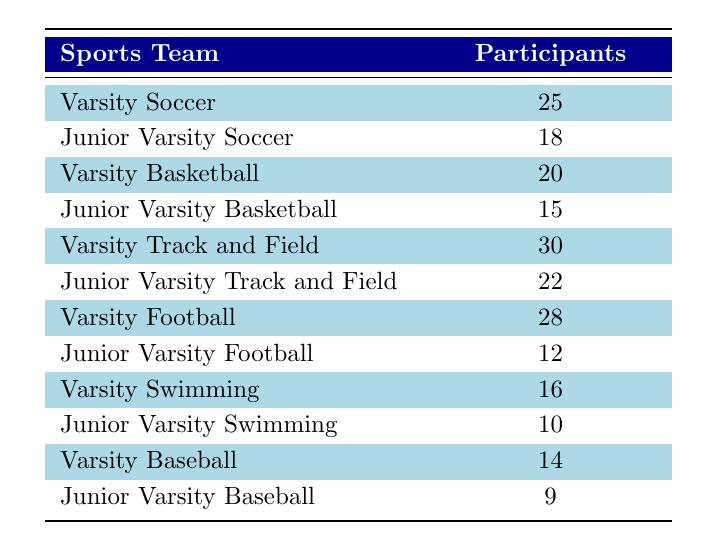What is the total number of participants in the Varsity Soccer and Varsity Basketball teams? The number of participants in Varsity Soccer is 25 and in Varsity Basketball is 20. Adding these together gives 25 + 20 = 45.
Answer: 45 Which team has the highest number of participants? By comparing the participant counts in each row, Varsity Track and Field has the highest number of participants with 30.
Answer: 30 How many more participants are in Junior Varsity Track and Field than in Junior Varsity Football? The Junior Varsity Track and Field team has 22 participants, while Junior Varsity Football has 12. Calculating the difference gives 22 - 12 = 10.
Answer: 10 Is the number of participants in Varsity Swimming greater than that of Junior Varsity Swimming? Varsity Swimming has 16 participants and Junior Varsity Swimming has 10. Since 16 is greater than 10, the answer is yes.
Answer: Yes What is the average number of participants across all Junior Varsity teams? Adding the participants from all Junior Varsity teams gives 18 (Soccer) + 15 (Basketball) + 22 (Track and Field) + 12 (Football) + 10 (Swimming) + 9 (Baseball) = 86. There are 6 Junior Varsity teams, so the average is 86 / 6 ≈ 14.33.
Answer: Approximately 14.33 Which sport has the least number of participants in any category? Looking across all teams, Junior Varsity Baseball has the least participants at 9.
Answer: 9 What is the difference in participants between the Varsity Football and Varsity Baseball teams? Varsity Football has 28 participants while Varsity Baseball has 14. The difference is calculated by subtracting: 28 - 14 = 14.
Answer: 14 Which two teams combined have a total of 38 participants? By examining the numbers, Junior Varsity Track and Field (22) and Junior Varsity Basketball (15) can be combined to total 22 + 15 = 37, which is not 38. However, Varsity Basketball (20) and Junior Varsity Football (12) total 20 + 12 = 32, still not 38. Therefore, check all combinations to find that Junior Varsity Football (12) and Junior Varsity Swimming (10) combined with Varsity Baseball (14) can yield 12 + 10 + 14 = 36, not meeting the criteria either. After re-evaluating, there's no such pair totaling 38.
Answer: No such pair How many teams have more than 20 participants? Teams with more than 20 participants include Varsity Track and Field (30), Varsity Football (28), Varsity Soccer (25), and Junior Varsity Track and Field (22). This totals 4 teams.
Answer: 4 